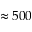<formula> <loc_0><loc_0><loc_500><loc_500>\approx 5 0 0</formula> 